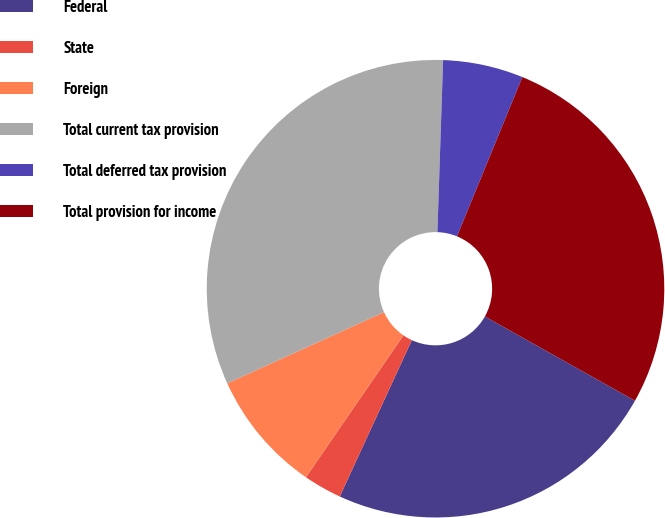Convert chart to OTSL. <chart><loc_0><loc_0><loc_500><loc_500><pie_chart><fcel>Federal<fcel>State<fcel>Foreign<fcel>Total current tax provision<fcel>Total deferred tax provision<fcel>Total provision for income<nl><fcel>23.73%<fcel>2.71%<fcel>8.63%<fcel>32.32%<fcel>5.67%<fcel>26.95%<nl></chart> 